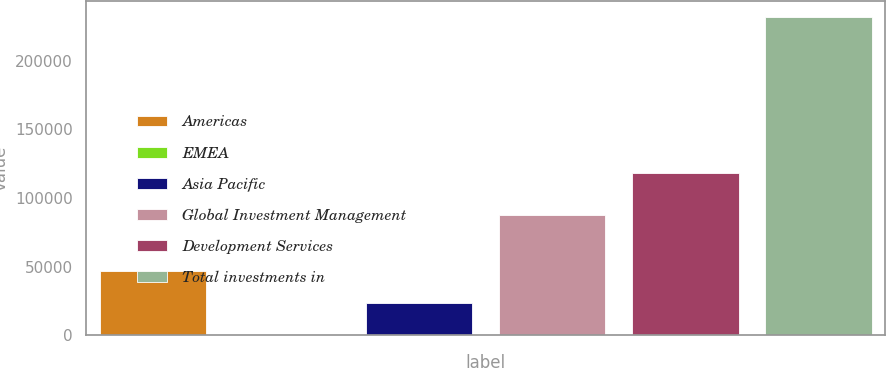Convert chart. <chart><loc_0><loc_0><loc_500><loc_500><bar_chart><fcel>Americas<fcel>EMEA<fcel>Asia Pacific<fcel>Global Investment Management<fcel>Development Services<fcel>Total investments in<nl><fcel>46758<fcel>388<fcel>23573<fcel>87501<fcel>118345<fcel>232238<nl></chart> 